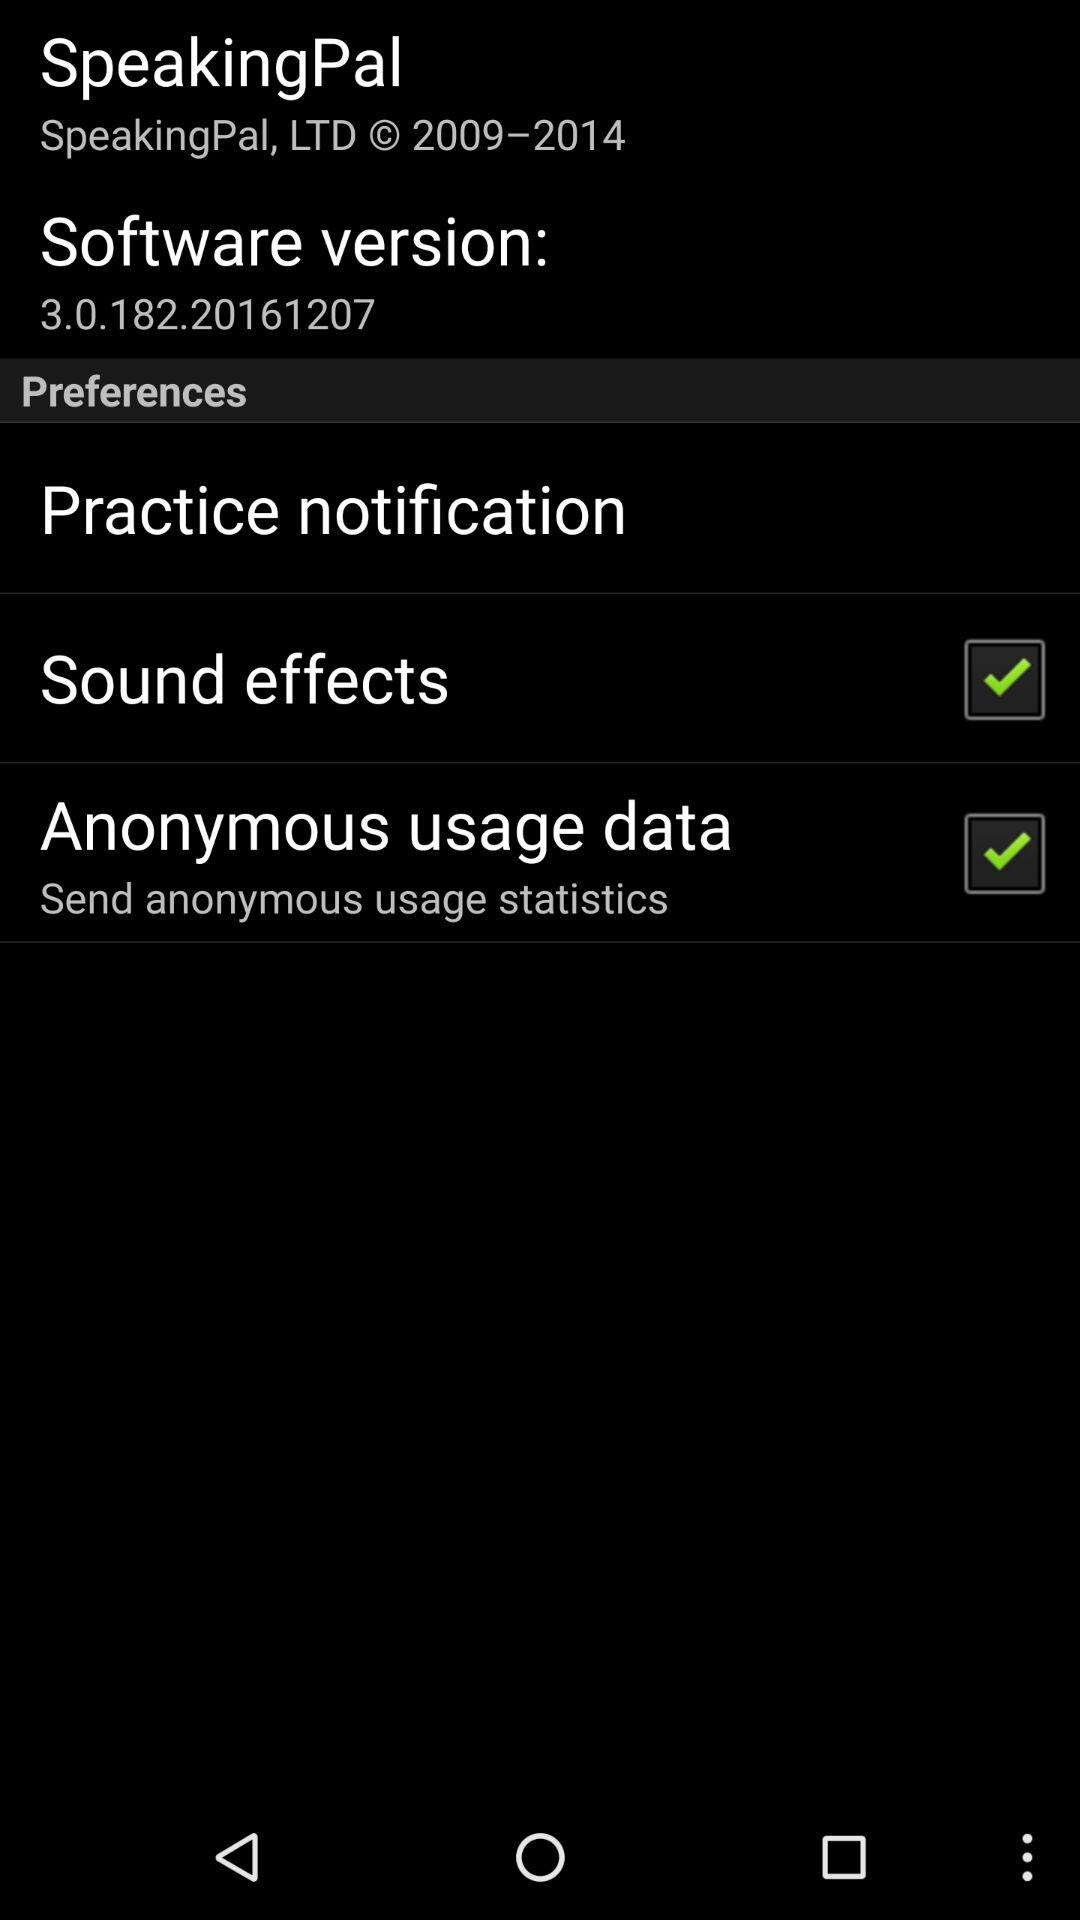What is the status of "Sound Effects"? The status is "on". 